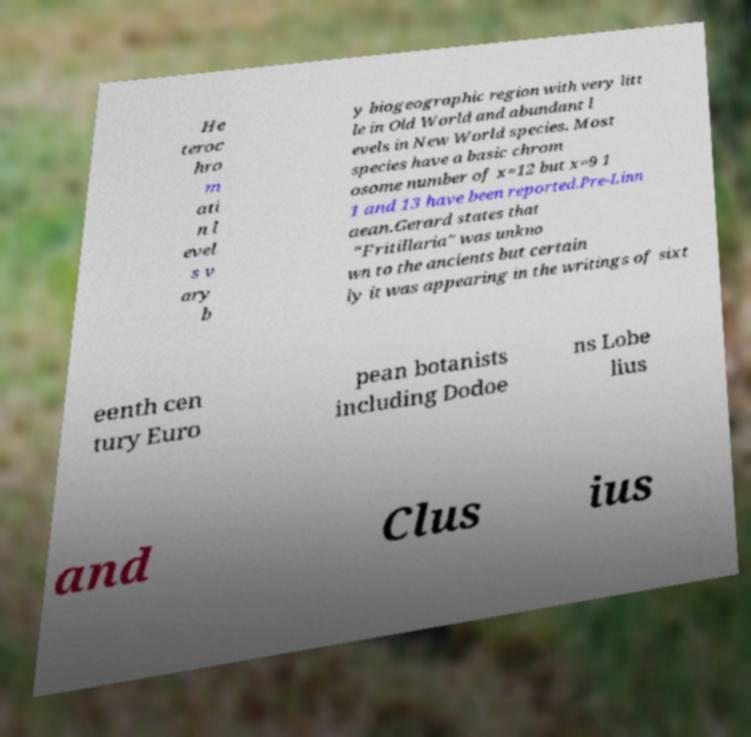Could you assist in decoding the text presented in this image and type it out clearly? He teroc hro m ati n l evel s v ary b y biogeographic region with very litt le in Old World and abundant l evels in New World species. Most species have a basic chrom osome number of x=12 but x=9 1 1 and 13 have been reported.Pre-Linn aean.Gerard states that "Fritillaria" was unkno wn to the ancients but certain ly it was appearing in the writings of sixt eenth cen tury Euro pean botanists including Dodoe ns Lobe lius and Clus ius 